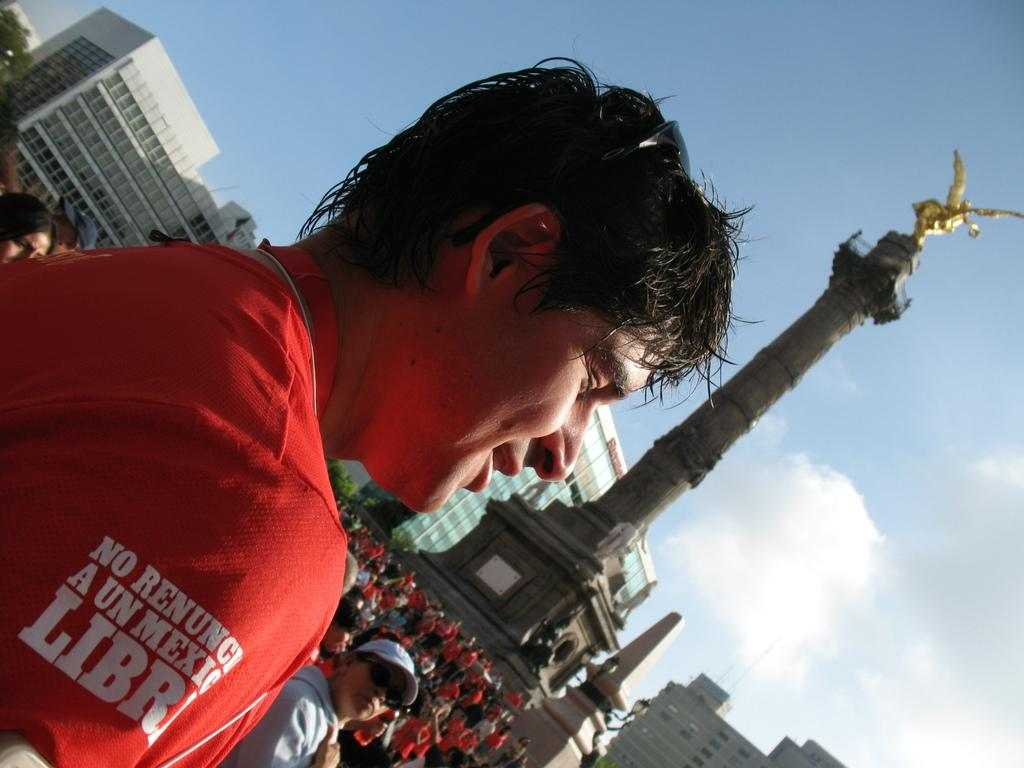Who is the main subject in the image? There is a man in the image. What is the man wearing? The man is wearing a red shirt. What can be seen in the background of the image? There are people and buildings in the background of the image. What is the central feature of the image? There is a tower in the center of the image. What is visible at the top of the image? The sky is visible at the top of the image. How many pizzas are on the page in the image? There is no page or pizza present in the image. What type of self-portrait is the man creating in the image? There is no self-portrait being created in the image; the man is simply standing there. 